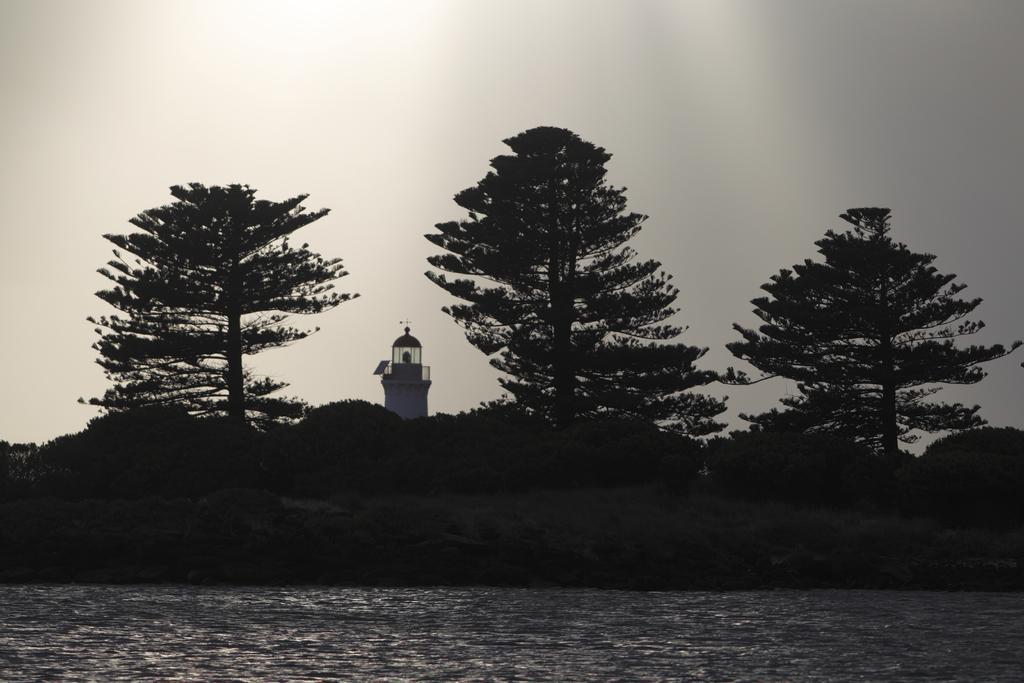Can you describe this image briefly? This is an outside view. At the bottom, I can see the water. In the middle of the image there are trees. In the background there is a tower. At the top of the image I can see the sky. 